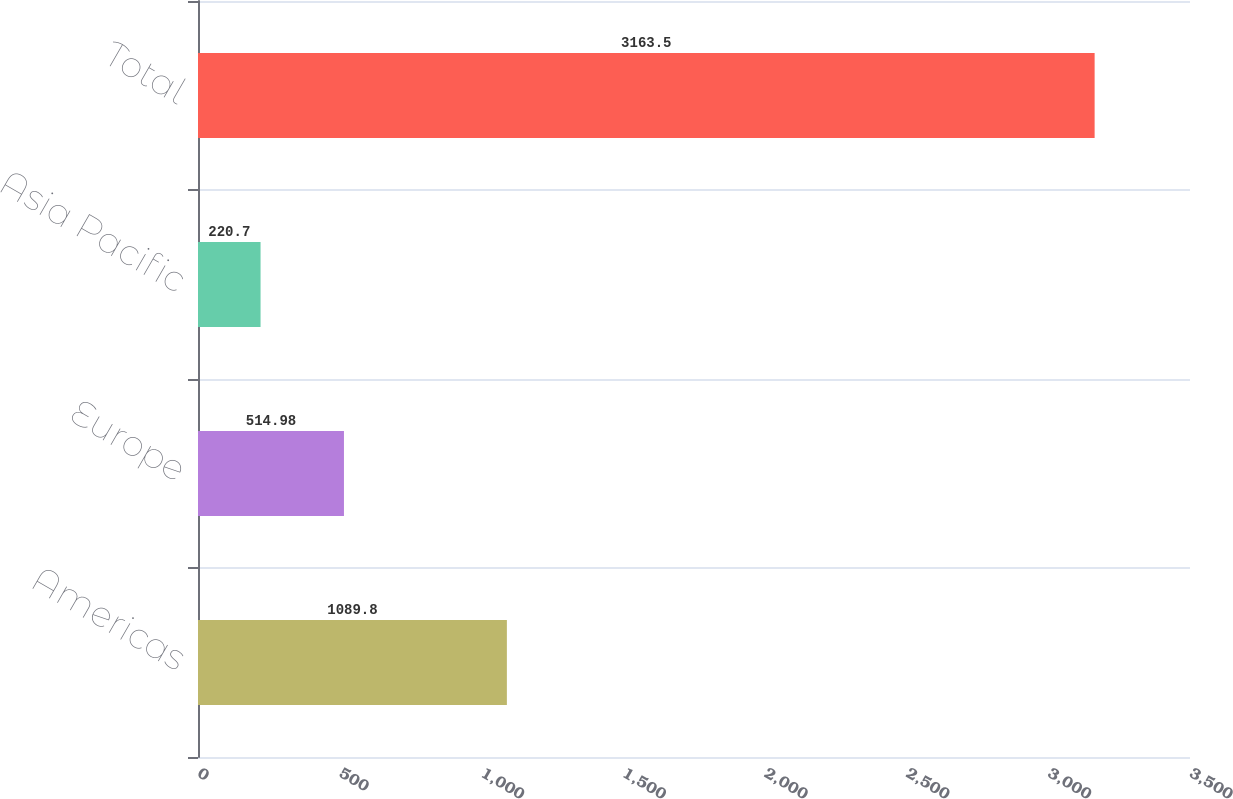Convert chart to OTSL. <chart><loc_0><loc_0><loc_500><loc_500><bar_chart><fcel>Americas<fcel>Europe<fcel>Asia Pacific<fcel>Total<nl><fcel>1089.8<fcel>514.98<fcel>220.7<fcel>3163.5<nl></chart> 